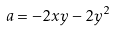Convert formula to latex. <formula><loc_0><loc_0><loc_500><loc_500>a = - 2 x y - 2 y ^ { 2 }</formula> 